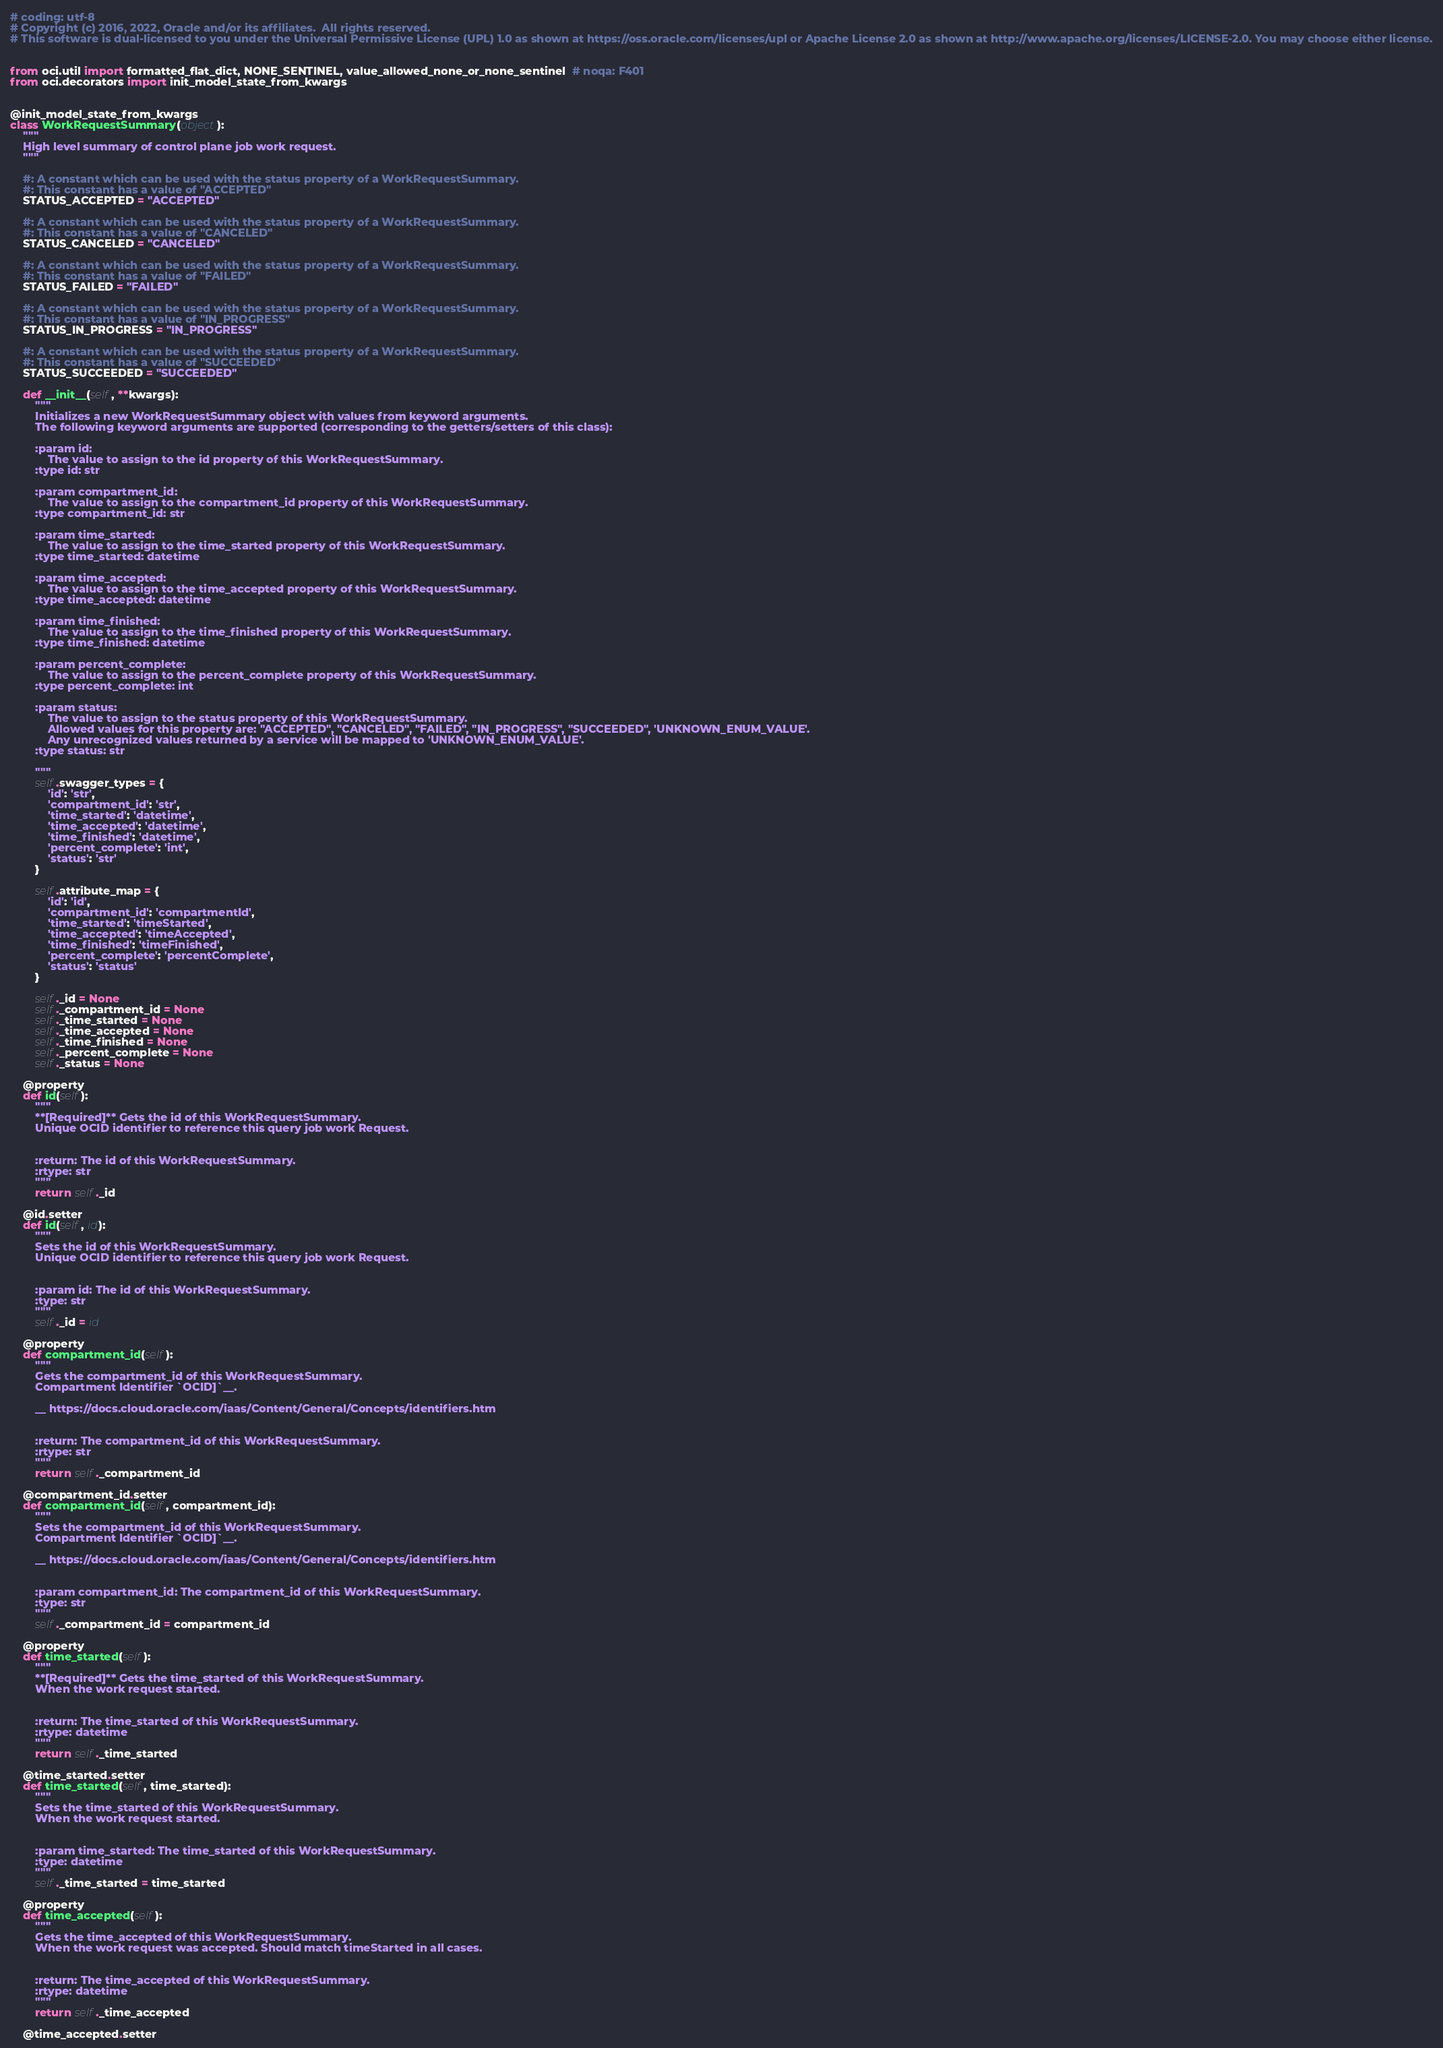Convert code to text. <code><loc_0><loc_0><loc_500><loc_500><_Python_># coding: utf-8
# Copyright (c) 2016, 2022, Oracle and/or its affiliates.  All rights reserved.
# This software is dual-licensed to you under the Universal Permissive License (UPL) 1.0 as shown at https://oss.oracle.com/licenses/upl or Apache License 2.0 as shown at http://www.apache.org/licenses/LICENSE-2.0. You may choose either license.


from oci.util import formatted_flat_dict, NONE_SENTINEL, value_allowed_none_or_none_sentinel  # noqa: F401
from oci.decorators import init_model_state_from_kwargs


@init_model_state_from_kwargs
class WorkRequestSummary(object):
    """
    High level summary of control plane job work request.
    """

    #: A constant which can be used with the status property of a WorkRequestSummary.
    #: This constant has a value of "ACCEPTED"
    STATUS_ACCEPTED = "ACCEPTED"

    #: A constant which can be used with the status property of a WorkRequestSummary.
    #: This constant has a value of "CANCELED"
    STATUS_CANCELED = "CANCELED"

    #: A constant which can be used with the status property of a WorkRequestSummary.
    #: This constant has a value of "FAILED"
    STATUS_FAILED = "FAILED"

    #: A constant which can be used with the status property of a WorkRequestSummary.
    #: This constant has a value of "IN_PROGRESS"
    STATUS_IN_PROGRESS = "IN_PROGRESS"

    #: A constant which can be used with the status property of a WorkRequestSummary.
    #: This constant has a value of "SUCCEEDED"
    STATUS_SUCCEEDED = "SUCCEEDED"

    def __init__(self, **kwargs):
        """
        Initializes a new WorkRequestSummary object with values from keyword arguments.
        The following keyword arguments are supported (corresponding to the getters/setters of this class):

        :param id:
            The value to assign to the id property of this WorkRequestSummary.
        :type id: str

        :param compartment_id:
            The value to assign to the compartment_id property of this WorkRequestSummary.
        :type compartment_id: str

        :param time_started:
            The value to assign to the time_started property of this WorkRequestSummary.
        :type time_started: datetime

        :param time_accepted:
            The value to assign to the time_accepted property of this WorkRequestSummary.
        :type time_accepted: datetime

        :param time_finished:
            The value to assign to the time_finished property of this WorkRequestSummary.
        :type time_finished: datetime

        :param percent_complete:
            The value to assign to the percent_complete property of this WorkRequestSummary.
        :type percent_complete: int

        :param status:
            The value to assign to the status property of this WorkRequestSummary.
            Allowed values for this property are: "ACCEPTED", "CANCELED", "FAILED", "IN_PROGRESS", "SUCCEEDED", 'UNKNOWN_ENUM_VALUE'.
            Any unrecognized values returned by a service will be mapped to 'UNKNOWN_ENUM_VALUE'.
        :type status: str

        """
        self.swagger_types = {
            'id': 'str',
            'compartment_id': 'str',
            'time_started': 'datetime',
            'time_accepted': 'datetime',
            'time_finished': 'datetime',
            'percent_complete': 'int',
            'status': 'str'
        }

        self.attribute_map = {
            'id': 'id',
            'compartment_id': 'compartmentId',
            'time_started': 'timeStarted',
            'time_accepted': 'timeAccepted',
            'time_finished': 'timeFinished',
            'percent_complete': 'percentComplete',
            'status': 'status'
        }

        self._id = None
        self._compartment_id = None
        self._time_started = None
        self._time_accepted = None
        self._time_finished = None
        self._percent_complete = None
        self._status = None

    @property
    def id(self):
        """
        **[Required]** Gets the id of this WorkRequestSummary.
        Unique OCID identifier to reference this query job work Request.


        :return: The id of this WorkRequestSummary.
        :rtype: str
        """
        return self._id

    @id.setter
    def id(self, id):
        """
        Sets the id of this WorkRequestSummary.
        Unique OCID identifier to reference this query job work Request.


        :param id: The id of this WorkRequestSummary.
        :type: str
        """
        self._id = id

    @property
    def compartment_id(self):
        """
        Gets the compartment_id of this WorkRequestSummary.
        Compartment Identifier `OCID]`__.

        __ https://docs.cloud.oracle.com/iaas/Content/General/Concepts/identifiers.htm


        :return: The compartment_id of this WorkRequestSummary.
        :rtype: str
        """
        return self._compartment_id

    @compartment_id.setter
    def compartment_id(self, compartment_id):
        """
        Sets the compartment_id of this WorkRequestSummary.
        Compartment Identifier `OCID]`__.

        __ https://docs.cloud.oracle.com/iaas/Content/General/Concepts/identifiers.htm


        :param compartment_id: The compartment_id of this WorkRequestSummary.
        :type: str
        """
        self._compartment_id = compartment_id

    @property
    def time_started(self):
        """
        **[Required]** Gets the time_started of this WorkRequestSummary.
        When the work request started.


        :return: The time_started of this WorkRequestSummary.
        :rtype: datetime
        """
        return self._time_started

    @time_started.setter
    def time_started(self, time_started):
        """
        Sets the time_started of this WorkRequestSummary.
        When the work request started.


        :param time_started: The time_started of this WorkRequestSummary.
        :type: datetime
        """
        self._time_started = time_started

    @property
    def time_accepted(self):
        """
        Gets the time_accepted of this WorkRequestSummary.
        When the work request was accepted. Should match timeStarted in all cases.


        :return: The time_accepted of this WorkRequestSummary.
        :rtype: datetime
        """
        return self._time_accepted

    @time_accepted.setter</code> 